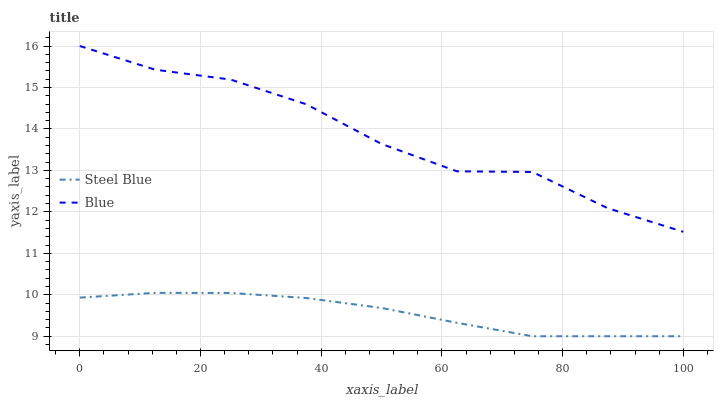Does Steel Blue have the minimum area under the curve?
Answer yes or no. Yes. Does Blue have the maximum area under the curve?
Answer yes or no. Yes. Does Steel Blue have the maximum area under the curve?
Answer yes or no. No. Is Steel Blue the smoothest?
Answer yes or no. Yes. Is Blue the roughest?
Answer yes or no. Yes. Is Steel Blue the roughest?
Answer yes or no. No. Does Steel Blue have the lowest value?
Answer yes or no. Yes. Does Blue have the highest value?
Answer yes or no. Yes. Does Steel Blue have the highest value?
Answer yes or no. No. Is Steel Blue less than Blue?
Answer yes or no. Yes. Is Blue greater than Steel Blue?
Answer yes or no. Yes. Does Steel Blue intersect Blue?
Answer yes or no. No. 